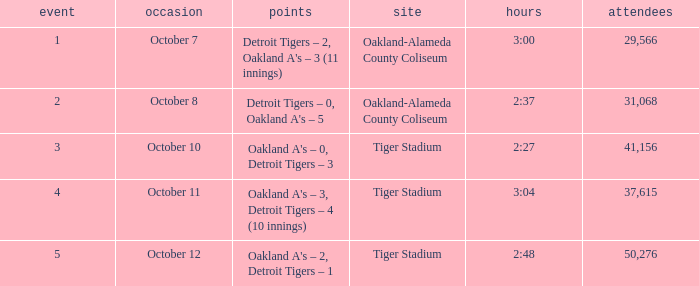What was the score at Tiger Stadium on October 12? Oakland A's – 2, Detroit Tigers – 1. 